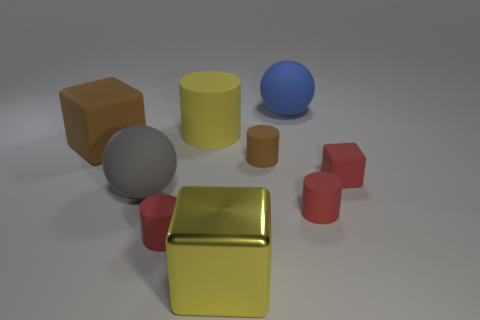What number of big spheres are behind the big gray thing?
Your response must be concise. 1. The shiny thing has what size?
Offer a terse response. Large. Does the brown object behind the brown cylinder have the same material as the sphere to the left of the yellow block?
Provide a succinct answer. Yes. Are there any matte blocks of the same color as the metallic object?
Provide a succinct answer. No. What is the color of the other rubber block that is the same size as the yellow cube?
Provide a succinct answer. Brown. Is the color of the large block that is on the right side of the big gray rubber thing the same as the big matte cylinder?
Keep it short and to the point. Yes. Are there any red things made of the same material as the big blue sphere?
Provide a succinct answer. Yes. The rubber object that is the same color as the large metallic thing is what shape?
Keep it short and to the point. Cylinder. Are there fewer large gray matte balls behind the yellow cylinder than large metal blocks?
Provide a short and direct response. Yes. Is the size of the ball in front of the red matte cube the same as the big blue rubber sphere?
Ensure brevity in your answer.  Yes. 